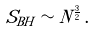Convert formula to latex. <formula><loc_0><loc_0><loc_500><loc_500>S _ { B H } \sim N ^ { \frac { 3 } { 2 } } \, .</formula> 